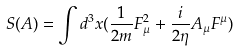Convert formula to latex. <formula><loc_0><loc_0><loc_500><loc_500>S ( A ) = \int d ^ { 3 } x ( \frac { 1 } { 2 m } F _ { \mu } ^ { 2 } + \frac { i } { 2 \eta } A _ { \mu } F ^ { \mu } )</formula> 